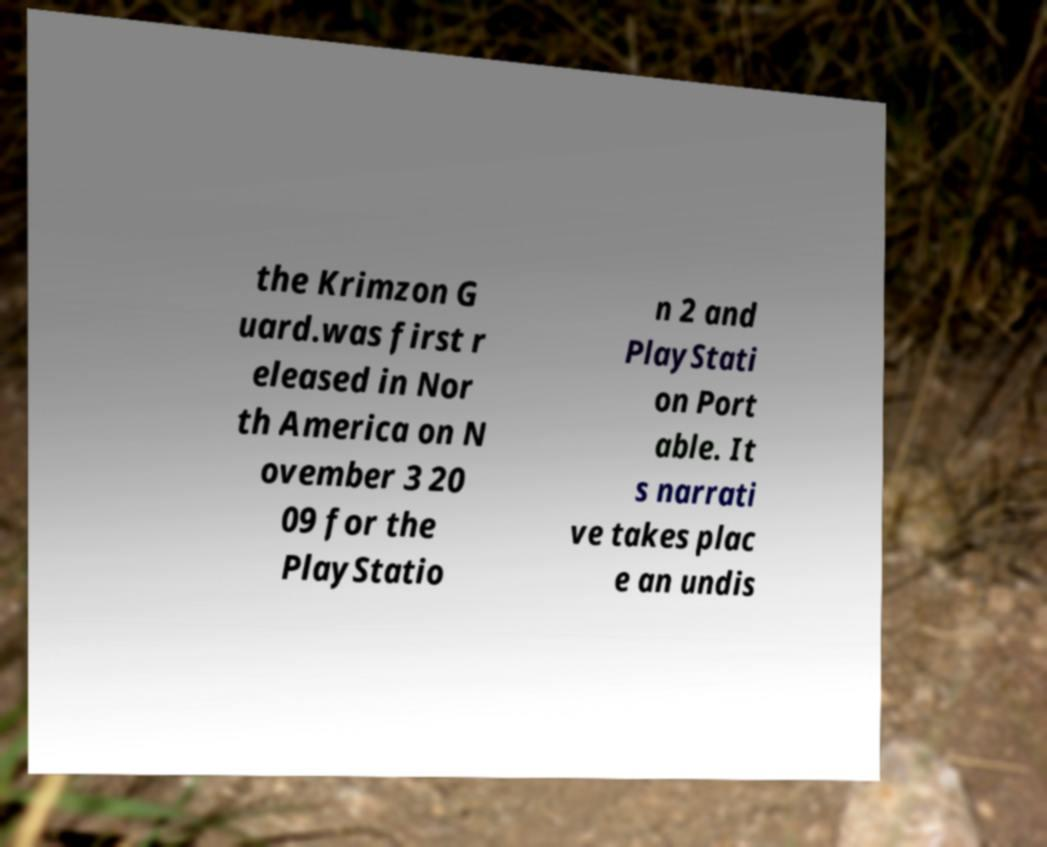I need the written content from this picture converted into text. Can you do that? the Krimzon G uard.was first r eleased in Nor th America on N ovember 3 20 09 for the PlayStatio n 2 and PlayStati on Port able. It s narrati ve takes plac e an undis 